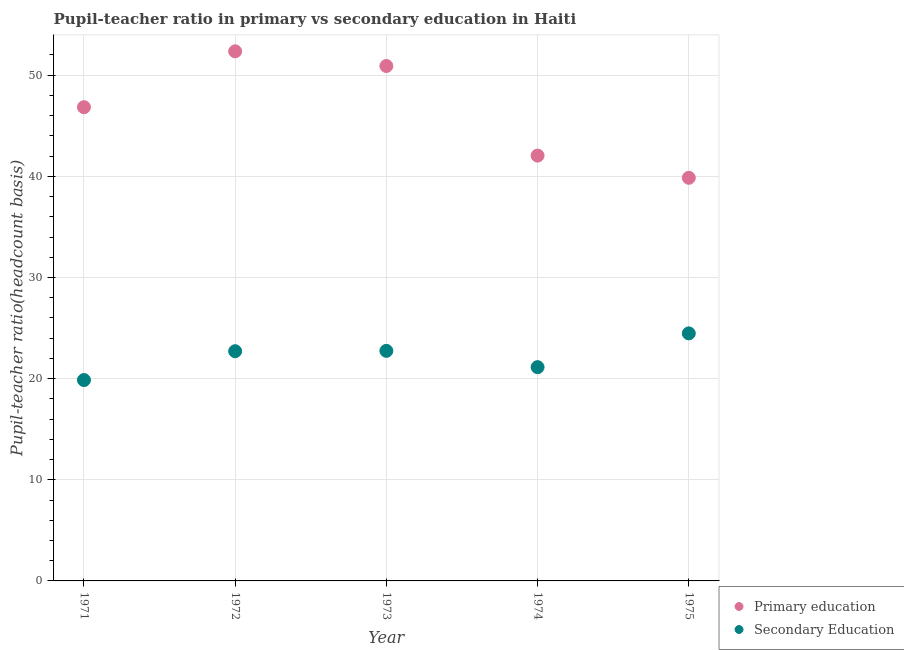How many different coloured dotlines are there?
Your response must be concise. 2. What is the pupil teacher ratio on secondary education in 1974?
Provide a succinct answer. 21.13. Across all years, what is the maximum pupil teacher ratio on secondary education?
Keep it short and to the point. 24.47. Across all years, what is the minimum pupil-teacher ratio in primary education?
Give a very brief answer. 39.85. In which year was the pupil-teacher ratio in primary education maximum?
Your response must be concise. 1972. In which year was the pupil-teacher ratio in primary education minimum?
Ensure brevity in your answer.  1975. What is the total pupil teacher ratio on secondary education in the graph?
Your answer should be compact. 110.92. What is the difference between the pupil-teacher ratio in primary education in 1973 and that in 1974?
Ensure brevity in your answer.  8.86. What is the difference between the pupil teacher ratio on secondary education in 1972 and the pupil-teacher ratio in primary education in 1971?
Keep it short and to the point. -24.12. What is the average pupil-teacher ratio in primary education per year?
Your answer should be compact. 46.4. In the year 1972, what is the difference between the pupil-teacher ratio in primary education and pupil teacher ratio on secondary education?
Ensure brevity in your answer.  29.65. In how many years, is the pupil-teacher ratio in primary education greater than 18?
Offer a very short reply. 5. What is the ratio of the pupil-teacher ratio in primary education in 1973 to that in 1975?
Provide a succinct answer. 1.28. Is the pupil teacher ratio on secondary education in 1972 less than that in 1973?
Offer a very short reply. Yes. What is the difference between the highest and the second highest pupil teacher ratio on secondary education?
Your answer should be compact. 1.73. What is the difference between the highest and the lowest pupil-teacher ratio in primary education?
Provide a short and direct response. 12.5. Is the sum of the pupil teacher ratio on secondary education in 1971 and 1974 greater than the maximum pupil-teacher ratio in primary education across all years?
Make the answer very short. No. Does the pupil teacher ratio on secondary education monotonically increase over the years?
Your answer should be very brief. No. Is the pupil-teacher ratio in primary education strictly greater than the pupil teacher ratio on secondary education over the years?
Ensure brevity in your answer.  Yes. Is the pupil-teacher ratio in primary education strictly less than the pupil teacher ratio on secondary education over the years?
Provide a succinct answer. No. How many years are there in the graph?
Offer a terse response. 5. What is the difference between two consecutive major ticks on the Y-axis?
Give a very brief answer. 10. Are the values on the major ticks of Y-axis written in scientific E-notation?
Offer a terse response. No. Does the graph contain grids?
Offer a very short reply. Yes. How many legend labels are there?
Ensure brevity in your answer.  2. What is the title of the graph?
Provide a succinct answer. Pupil-teacher ratio in primary vs secondary education in Haiti. What is the label or title of the X-axis?
Give a very brief answer. Year. What is the label or title of the Y-axis?
Your answer should be compact. Pupil-teacher ratio(headcount basis). What is the Pupil-teacher ratio(headcount basis) in Primary education in 1971?
Your response must be concise. 46.83. What is the Pupil-teacher ratio(headcount basis) in Secondary Education in 1971?
Provide a succinct answer. 19.86. What is the Pupil-teacher ratio(headcount basis) in Primary education in 1972?
Offer a terse response. 52.36. What is the Pupil-teacher ratio(headcount basis) in Secondary Education in 1972?
Make the answer very short. 22.71. What is the Pupil-teacher ratio(headcount basis) in Primary education in 1973?
Offer a very short reply. 50.91. What is the Pupil-teacher ratio(headcount basis) of Secondary Education in 1973?
Keep it short and to the point. 22.74. What is the Pupil-teacher ratio(headcount basis) of Primary education in 1974?
Offer a very short reply. 42.05. What is the Pupil-teacher ratio(headcount basis) in Secondary Education in 1974?
Your answer should be compact. 21.13. What is the Pupil-teacher ratio(headcount basis) of Primary education in 1975?
Offer a terse response. 39.85. What is the Pupil-teacher ratio(headcount basis) in Secondary Education in 1975?
Provide a short and direct response. 24.47. Across all years, what is the maximum Pupil-teacher ratio(headcount basis) of Primary education?
Your answer should be very brief. 52.36. Across all years, what is the maximum Pupil-teacher ratio(headcount basis) of Secondary Education?
Make the answer very short. 24.47. Across all years, what is the minimum Pupil-teacher ratio(headcount basis) in Primary education?
Your response must be concise. 39.85. Across all years, what is the minimum Pupil-teacher ratio(headcount basis) of Secondary Education?
Offer a terse response. 19.86. What is the total Pupil-teacher ratio(headcount basis) of Primary education in the graph?
Provide a succinct answer. 232. What is the total Pupil-teacher ratio(headcount basis) of Secondary Education in the graph?
Offer a very short reply. 110.92. What is the difference between the Pupil-teacher ratio(headcount basis) of Primary education in 1971 and that in 1972?
Ensure brevity in your answer.  -5.52. What is the difference between the Pupil-teacher ratio(headcount basis) in Secondary Education in 1971 and that in 1972?
Your answer should be compact. -2.85. What is the difference between the Pupil-teacher ratio(headcount basis) in Primary education in 1971 and that in 1973?
Your answer should be very brief. -4.07. What is the difference between the Pupil-teacher ratio(headcount basis) of Secondary Education in 1971 and that in 1973?
Offer a very short reply. -2.89. What is the difference between the Pupil-teacher ratio(headcount basis) in Primary education in 1971 and that in 1974?
Provide a succinct answer. 4.79. What is the difference between the Pupil-teacher ratio(headcount basis) in Secondary Education in 1971 and that in 1974?
Provide a succinct answer. -1.28. What is the difference between the Pupil-teacher ratio(headcount basis) in Primary education in 1971 and that in 1975?
Give a very brief answer. 6.98. What is the difference between the Pupil-teacher ratio(headcount basis) in Secondary Education in 1971 and that in 1975?
Make the answer very short. -4.62. What is the difference between the Pupil-teacher ratio(headcount basis) in Primary education in 1972 and that in 1973?
Keep it short and to the point. 1.45. What is the difference between the Pupil-teacher ratio(headcount basis) of Secondary Education in 1972 and that in 1973?
Provide a short and direct response. -0.04. What is the difference between the Pupil-teacher ratio(headcount basis) in Primary education in 1972 and that in 1974?
Offer a terse response. 10.31. What is the difference between the Pupil-teacher ratio(headcount basis) of Secondary Education in 1972 and that in 1974?
Provide a succinct answer. 1.58. What is the difference between the Pupil-teacher ratio(headcount basis) of Primary education in 1972 and that in 1975?
Your answer should be very brief. 12.5. What is the difference between the Pupil-teacher ratio(headcount basis) in Secondary Education in 1972 and that in 1975?
Provide a succinct answer. -1.76. What is the difference between the Pupil-teacher ratio(headcount basis) in Primary education in 1973 and that in 1974?
Give a very brief answer. 8.86. What is the difference between the Pupil-teacher ratio(headcount basis) of Secondary Education in 1973 and that in 1974?
Provide a short and direct response. 1.61. What is the difference between the Pupil-teacher ratio(headcount basis) in Primary education in 1973 and that in 1975?
Provide a short and direct response. 11.05. What is the difference between the Pupil-teacher ratio(headcount basis) of Secondary Education in 1973 and that in 1975?
Provide a succinct answer. -1.73. What is the difference between the Pupil-teacher ratio(headcount basis) of Primary education in 1974 and that in 1975?
Ensure brevity in your answer.  2.19. What is the difference between the Pupil-teacher ratio(headcount basis) of Secondary Education in 1974 and that in 1975?
Your answer should be compact. -3.34. What is the difference between the Pupil-teacher ratio(headcount basis) in Primary education in 1971 and the Pupil-teacher ratio(headcount basis) in Secondary Education in 1972?
Provide a short and direct response. 24.12. What is the difference between the Pupil-teacher ratio(headcount basis) in Primary education in 1971 and the Pupil-teacher ratio(headcount basis) in Secondary Education in 1973?
Keep it short and to the point. 24.09. What is the difference between the Pupil-teacher ratio(headcount basis) in Primary education in 1971 and the Pupil-teacher ratio(headcount basis) in Secondary Education in 1974?
Your answer should be very brief. 25.7. What is the difference between the Pupil-teacher ratio(headcount basis) of Primary education in 1971 and the Pupil-teacher ratio(headcount basis) of Secondary Education in 1975?
Offer a very short reply. 22.36. What is the difference between the Pupil-teacher ratio(headcount basis) of Primary education in 1972 and the Pupil-teacher ratio(headcount basis) of Secondary Education in 1973?
Your response must be concise. 29.61. What is the difference between the Pupil-teacher ratio(headcount basis) of Primary education in 1972 and the Pupil-teacher ratio(headcount basis) of Secondary Education in 1974?
Offer a terse response. 31.22. What is the difference between the Pupil-teacher ratio(headcount basis) in Primary education in 1972 and the Pupil-teacher ratio(headcount basis) in Secondary Education in 1975?
Your answer should be very brief. 27.89. What is the difference between the Pupil-teacher ratio(headcount basis) in Primary education in 1973 and the Pupil-teacher ratio(headcount basis) in Secondary Education in 1974?
Your response must be concise. 29.77. What is the difference between the Pupil-teacher ratio(headcount basis) of Primary education in 1973 and the Pupil-teacher ratio(headcount basis) of Secondary Education in 1975?
Ensure brevity in your answer.  26.43. What is the difference between the Pupil-teacher ratio(headcount basis) of Primary education in 1974 and the Pupil-teacher ratio(headcount basis) of Secondary Education in 1975?
Ensure brevity in your answer.  17.57. What is the average Pupil-teacher ratio(headcount basis) of Primary education per year?
Offer a very short reply. 46.4. What is the average Pupil-teacher ratio(headcount basis) in Secondary Education per year?
Your answer should be very brief. 22.18. In the year 1971, what is the difference between the Pupil-teacher ratio(headcount basis) in Primary education and Pupil-teacher ratio(headcount basis) in Secondary Education?
Your response must be concise. 26.98. In the year 1972, what is the difference between the Pupil-teacher ratio(headcount basis) in Primary education and Pupil-teacher ratio(headcount basis) in Secondary Education?
Give a very brief answer. 29.65. In the year 1973, what is the difference between the Pupil-teacher ratio(headcount basis) in Primary education and Pupil-teacher ratio(headcount basis) in Secondary Education?
Ensure brevity in your answer.  28.16. In the year 1974, what is the difference between the Pupil-teacher ratio(headcount basis) in Primary education and Pupil-teacher ratio(headcount basis) in Secondary Education?
Offer a very short reply. 20.91. In the year 1975, what is the difference between the Pupil-teacher ratio(headcount basis) in Primary education and Pupil-teacher ratio(headcount basis) in Secondary Education?
Ensure brevity in your answer.  15.38. What is the ratio of the Pupil-teacher ratio(headcount basis) of Primary education in 1971 to that in 1972?
Keep it short and to the point. 0.89. What is the ratio of the Pupil-teacher ratio(headcount basis) in Secondary Education in 1971 to that in 1972?
Provide a short and direct response. 0.87. What is the ratio of the Pupil-teacher ratio(headcount basis) of Secondary Education in 1971 to that in 1973?
Offer a terse response. 0.87. What is the ratio of the Pupil-teacher ratio(headcount basis) of Primary education in 1971 to that in 1974?
Make the answer very short. 1.11. What is the ratio of the Pupil-teacher ratio(headcount basis) of Secondary Education in 1971 to that in 1974?
Provide a succinct answer. 0.94. What is the ratio of the Pupil-teacher ratio(headcount basis) in Primary education in 1971 to that in 1975?
Your answer should be very brief. 1.18. What is the ratio of the Pupil-teacher ratio(headcount basis) in Secondary Education in 1971 to that in 1975?
Offer a very short reply. 0.81. What is the ratio of the Pupil-teacher ratio(headcount basis) in Primary education in 1972 to that in 1973?
Offer a terse response. 1.03. What is the ratio of the Pupil-teacher ratio(headcount basis) in Secondary Education in 1972 to that in 1973?
Your answer should be compact. 1. What is the ratio of the Pupil-teacher ratio(headcount basis) of Primary education in 1972 to that in 1974?
Your answer should be compact. 1.25. What is the ratio of the Pupil-teacher ratio(headcount basis) of Secondary Education in 1972 to that in 1974?
Ensure brevity in your answer.  1.07. What is the ratio of the Pupil-teacher ratio(headcount basis) in Primary education in 1972 to that in 1975?
Provide a succinct answer. 1.31. What is the ratio of the Pupil-teacher ratio(headcount basis) of Secondary Education in 1972 to that in 1975?
Give a very brief answer. 0.93. What is the ratio of the Pupil-teacher ratio(headcount basis) of Primary education in 1973 to that in 1974?
Offer a terse response. 1.21. What is the ratio of the Pupil-teacher ratio(headcount basis) of Secondary Education in 1973 to that in 1974?
Provide a succinct answer. 1.08. What is the ratio of the Pupil-teacher ratio(headcount basis) in Primary education in 1973 to that in 1975?
Provide a short and direct response. 1.28. What is the ratio of the Pupil-teacher ratio(headcount basis) of Secondary Education in 1973 to that in 1975?
Provide a short and direct response. 0.93. What is the ratio of the Pupil-teacher ratio(headcount basis) of Primary education in 1974 to that in 1975?
Give a very brief answer. 1.05. What is the ratio of the Pupil-teacher ratio(headcount basis) of Secondary Education in 1974 to that in 1975?
Give a very brief answer. 0.86. What is the difference between the highest and the second highest Pupil-teacher ratio(headcount basis) of Primary education?
Offer a terse response. 1.45. What is the difference between the highest and the second highest Pupil-teacher ratio(headcount basis) in Secondary Education?
Give a very brief answer. 1.73. What is the difference between the highest and the lowest Pupil-teacher ratio(headcount basis) of Primary education?
Provide a succinct answer. 12.5. What is the difference between the highest and the lowest Pupil-teacher ratio(headcount basis) in Secondary Education?
Your answer should be compact. 4.62. 